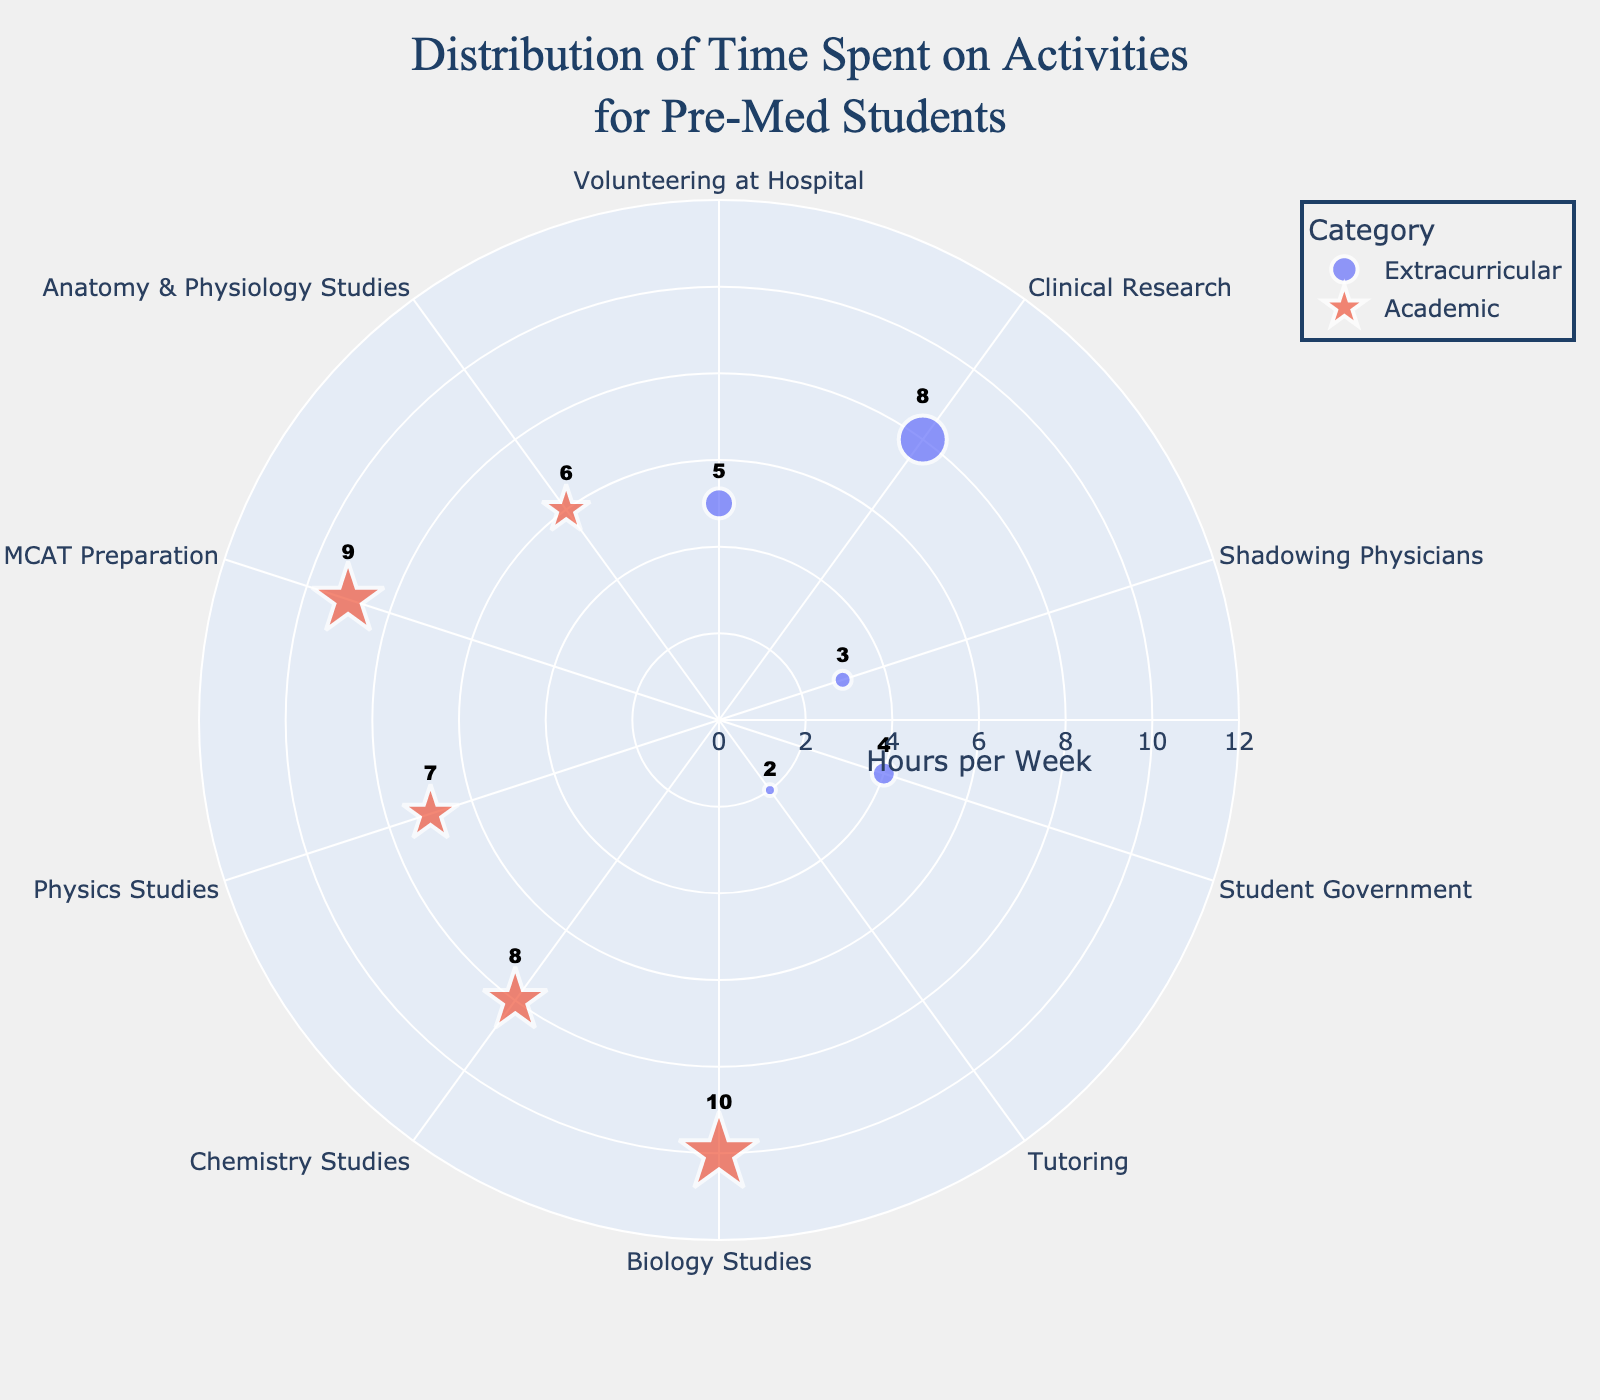What is the title of the chart? The title is typically found at the top of the chart, centered and in a larger font size than other text. In this case, it reads "Distribution of Time Spent on Activities for Pre-Med Students."
Answer: Distribution of Time Spent on Activities for Pre-Med Students How many academic activities are represented in the chart? Academic activities are marked with star symbols in the chart. By counting these symbols, we can see there are five academic activities.
Answer: 5 What is the range of hours per week for the radial axis? The radial axis range is often labeled alongside the axis. Here, it ranges from 0 to 12 hours per week, which includes a buffer of 2 hours above the maximum value.
Answer: 0 to 12 Which activity has the highest hours per week, and how many hours is it? The activity with the largest symbol and highest radial distance on the chart is "Biology Studies," which has 10 hours per week.
Answer: Biology Studies, 10 How many extracurricular activities are represented and what are they? Extracurricular activities are marked with circle symbols in the chart. There are five: Volunteering at Hospital, Clinical Research, Shadowing Physicians, Student Government, and Tutoring.
Answer: 5: Volunteering at Hospital, Clinical Research, Shadowing Physicians, Student Government, Tutoring What is the total amount of hours spent on extracurricular activities? Sum the hours for all extracurricular activities: 5 (Volunteering) + 8 (Research) + 3 (Shadowing) + 4 (Student Government) + 2 (Tutoring) = 22 hours.
Answer: 22 Comparing "MCAT Preparation" and "Chemistry Studies," which one requires more hours per week? Both activities can be compared by looking at their markers. MCAT Preparation has 9 hours per week, while Chemistry Studies has 8 hours per week. Therefore, MCAT Preparation requires more hours.
Answer: MCAT Preparation What is the average number of hours spent on academic activities? Sum the hours for academic activities and divide by their count: (10 + 8 + 7 + 9 + 6) / 5 = 40 / 5 = 8 hours per week.
Answer: 8 How does the time spent on "Shadowing Physicians" compare to "Student Government"? Both are extracurricular activities marked by different circle positions. Shadowing Physicians shows 3 hours per week, while Student Government shows 4 hours per week, so Student Government requires more time.
Answer: Student Government requires more time Which category has the most variation in hours spent per week? Variation can be seen by the range of radial distances within each category. Extracurricular activities vary from 2 to 8 hours (a range of 6 hours), while academic activities vary from 6 to 10 hours (a range of 4 hours). Hence, extracurricular activities have more variation.
Answer: Extracurricular 